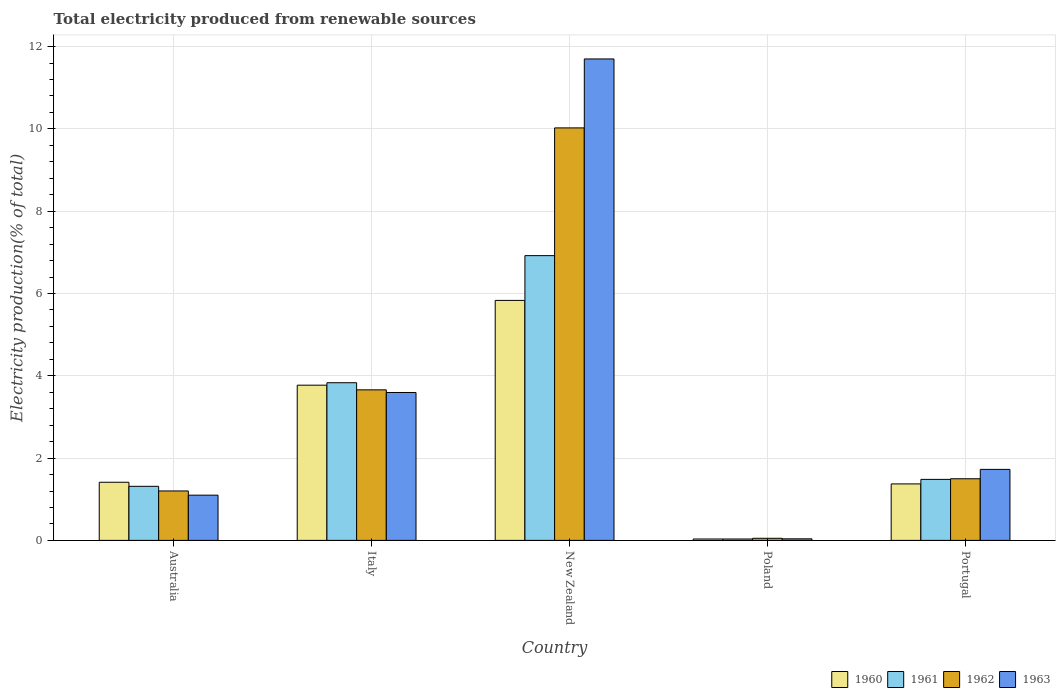How many different coloured bars are there?
Give a very brief answer. 4. Are the number of bars on each tick of the X-axis equal?
Provide a short and direct response. Yes. What is the label of the 3rd group of bars from the left?
Ensure brevity in your answer.  New Zealand. What is the total electricity produced in 1963 in Italy?
Provide a succinct answer. 3.59. Across all countries, what is the maximum total electricity produced in 1963?
Provide a succinct answer. 11.7. Across all countries, what is the minimum total electricity produced in 1963?
Provide a succinct answer. 0.04. In which country was the total electricity produced in 1962 maximum?
Your response must be concise. New Zealand. What is the total total electricity produced in 1960 in the graph?
Provide a succinct answer. 12.42. What is the difference between the total electricity produced in 1962 in New Zealand and that in Portugal?
Your answer should be very brief. 8.53. What is the difference between the total electricity produced in 1962 in Poland and the total electricity produced in 1960 in New Zealand?
Offer a terse response. -5.78. What is the average total electricity produced in 1961 per country?
Ensure brevity in your answer.  2.72. What is the difference between the total electricity produced of/in 1962 and total electricity produced of/in 1963 in Italy?
Give a very brief answer. 0.06. In how many countries, is the total electricity produced in 1961 greater than 6 %?
Provide a succinct answer. 1. What is the ratio of the total electricity produced in 1962 in Poland to that in Portugal?
Your answer should be compact. 0.03. Is the total electricity produced in 1963 in Australia less than that in Poland?
Your answer should be compact. No. Is the difference between the total electricity produced in 1962 in Poland and Portugal greater than the difference between the total electricity produced in 1963 in Poland and Portugal?
Keep it short and to the point. Yes. What is the difference between the highest and the second highest total electricity produced in 1962?
Offer a very short reply. -8.53. What is the difference between the highest and the lowest total electricity produced in 1962?
Give a very brief answer. 9.97. In how many countries, is the total electricity produced in 1960 greater than the average total electricity produced in 1960 taken over all countries?
Provide a succinct answer. 2. Is it the case that in every country, the sum of the total electricity produced in 1962 and total electricity produced in 1961 is greater than the sum of total electricity produced in 1960 and total electricity produced in 1963?
Give a very brief answer. No. What does the 1st bar from the left in Italy represents?
Provide a succinct answer. 1960. Is it the case that in every country, the sum of the total electricity produced in 1962 and total electricity produced in 1961 is greater than the total electricity produced in 1960?
Give a very brief answer. Yes. How many bars are there?
Provide a succinct answer. 20. Are all the bars in the graph horizontal?
Offer a terse response. No. What is the difference between two consecutive major ticks on the Y-axis?
Keep it short and to the point. 2. Does the graph contain any zero values?
Provide a succinct answer. No. Where does the legend appear in the graph?
Give a very brief answer. Bottom right. How many legend labels are there?
Your answer should be very brief. 4. How are the legend labels stacked?
Offer a very short reply. Horizontal. What is the title of the graph?
Your answer should be compact. Total electricity produced from renewable sources. What is the label or title of the X-axis?
Offer a very short reply. Country. What is the label or title of the Y-axis?
Provide a succinct answer. Electricity production(% of total). What is the Electricity production(% of total) of 1960 in Australia?
Make the answer very short. 1.41. What is the Electricity production(% of total) of 1961 in Australia?
Make the answer very short. 1.31. What is the Electricity production(% of total) in 1962 in Australia?
Ensure brevity in your answer.  1.2. What is the Electricity production(% of total) in 1963 in Australia?
Make the answer very short. 1.1. What is the Electricity production(% of total) of 1960 in Italy?
Provide a short and direct response. 3.77. What is the Electricity production(% of total) in 1961 in Italy?
Your answer should be very brief. 3.83. What is the Electricity production(% of total) of 1962 in Italy?
Provide a short and direct response. 3.66. What is the Electricity production(% of total) of 1963 in Italy?
Your response must be concise. 3.59. What is the Electricity production(% of total) of 1960 in New Zealand?
Make the answer very short. 5.83. What is the Electricity production(% of total) of 1961 in New Zealand?
Give a very brief answer. 6.92. What is the Electricity production(% of total) in 1962 in New Zealand?
Your response must be concise. 10.02. What is the Electricity production(% of total) of 1963 in New Zealand?
Your answer should be compact. 11.7. What is the Electricity production(% of total) of 1960 in Poland?
Make the answer very short. 0.03. What is the Electricity production(% of total) of 1961 in Poland?
Provide a short and direct response. 0.03. What is the Electricity production(% of total) of 1962 in Poland?
Give a very brief answer. 0.05. What is the Electricity production(% of total) of 1963 in Poland?
Keep it short and to the point. 0.04. What is the Electricity production(% of total) of 1960 in Portugal?
Provide a short and direct response. 1.37. What is the Electricity production(% of total) of 1961 in Portugal?
Provide a short and direct response. 1.48. What is the Electricity production(% of total) of 1962 in Portugal?
Provide a short and direct response. 1.5. What is the Electricity production(% of total) in 1963 in Portugal?
Provide a short and direct response. 1.73. Across all countries, what is the maximum Electricity production(% of total) in 1960?
Your response must be concise. 5.83. Across all countries, what is the maximum Electricity production(% of total) in 1961?
Offer a very short reply. 6.92. Across all countries, what is the maximum Electricity production(% of total) of 1962?
Give a very brief answer. 10.02. Across all countries, what is the maximum Electricity production(% of total) in 1963?
Keep it short and to the point. 11.7. Across all countries, what is the minimum Electricity production(% of total) in 1960?
Give a very brief answer. 0.03. Across all countries, what is the minimum Electricity production(% of total) of 1961?
Your response must be concise. 0.03. Across all countries, what is the minimum Electricity production(% of total) in 1962?
Ensure brevity in your answer.  0.05. Across all countries, what is the minimum Electricity production(% of total) in 1963?
Your response must be concise. 0.04. What is the total Electricity production(% of total) in 1960 in the graph?
Your response must be concise. 12.42. What is the total Electricity production(% of total) of 1961 in the graph?
Offer a very short reply. 13.58. What is the total Electricity production(% of total) of 1962 in the graph?
Offer a terse response. 16.43. What is the total Electricity production(% of total) in 1963 in the graph?
Ensure brevity in your answer.  18.16. What is the difference between the Electricity production(% of total) in 1960 in Australia and that in Italy?
Your answer should be very brief. -2.36. What is the difference between the Electricity production(% of total) in 1961 in Australia and that in Italy?
Make the answer very short. -2.52. What is the difference between the Electricity production(% of total) in 1962 in Australia and that in Italy?
Ensure brevity in your answer.  -2.46. What is the difference between the Electricity production(% of total) in 1963 in Australia and that in Italy?
Ensure brevity in your answer.  -2.5. What is the difference between the Electricity production(% of total) in 1960 in Australia and that in New Zealand?
Your answer should be compact. -4.42. What is the difference between the Electricity production(% of total) of 1961 in Australia and that in New Zealand?
Your answer should be very brief. -5.61. What is the difference between the Electricity production(% of total) of 1962 in Australia and that in New Zealand?
Your answer should be very brief. -8.82. What is the difference between the Electricity production(% of total) of 1963 in Australia and that in New Zealand?
Offer a very short reply. -10.6. What is the difference between the Electricity production(% of total) of 1960 in Australia and that in Poland?
Offer a terse response. 1.38. What is the difference between the Electricity production(% of total) in 1961 in Australia and that in Poland?
Offer a terse response. 1.28. What is the difference between the Electricity production(% of total) in 1962 in Australia and that in Poland?
Your answer should be very brief. 1.15. What is the difference between the Electricity production(% of total) of 1963 in Australia and that in Poland?
Ensure brevity in your answer.  1.06. What is the difference between the Electricity production(% of total) in 1960 in Australia and that in Portugal?
Ensure brevity in your answer.  0.04. What is the difference between the Electricity production(% of total) in 1961 in Australia and that in Portugal?
Provide a succinct answer. -0.17. What is the difference between the Electricity production(% of total) of 1962 in Australia and that in Portugal?
Your response must be concise. -0.3. What is the difference between the Electricity production(% of total) in 1963 in Australia and that in Portugal?
Keep it short and to the point. -0.63. What is the difference between the Electricity production(% of total) of 1960 in Italy and that in New Zealand?
Make the answer very short. -2.06. What is the difference between the Electricity production(% of total) in 1961 in Italy and that in New Zealand?
Offer a very short reply. -3.09. What is the difference between the Electricity production(% of total) in 1962 in Italy and that in New Zealand?
Make the answer very short. -6.37. What is the difference between the Electricity production(% of total) in 1963 in Italy and that in New Zealand?
Give a very brief answer. -8.11. What is the difference between the Electricity production(% of total) in 1960 in Italy and that in Poland?
Give a very brief answer. 3.74. What is the difference between the Electricity production(% of total) in 1961 in Italy and that in Poland?
Provide a succinct answer. 3.8. What is the difference between the Electricity production(% of total) in 1962 in Italy and that in Poland?
Give a very brief answer. 3.61. What is the difference between the Electricity production(% of total) of 1963 in Italy and that in Poland?
Give a very brief answer. 3.56. What is the difference between the Electricity production(% of total) in 1960 in Italy and that in Portugal?
Your answer should be compact. 2.4. What is the difference between the Electricity production(% of total) of 1961 in Italy and that in Portugal?
Ensure brevity in your answer.  2.35. What is the difference between the Electricity production(% of total) of 1962 in Italy and that in Portugal?
Offer a very short reply. 2.16. What is the difference between the Electricity production(% of total) of 1963 in Italy and that in Portugal?
Make the answer very short. 1.87. What is the difference between the Electricity production(% of total) of 1960 in New Zealand and that in Poland?
Give a very brief answer. 5.8. What is the difference between the Electricity production(% of total) in 1961 in New Zealand and that in Poland?
Ensure brevity in your answer.  6.89. What is the difference between the Electricity production(% of total) of 1962 in New Zealand and that in Poland?
Offer a terse response. 9.97. What is the difference between the Electricity production(% of total) of 1963 in New Zealand and that in Poland?
Offer a very short reply. 11.66. What is the difference between the Electricity production(% of total) in 1960 in New Zealand and that in Portugal?
Offer a terse response. 4.46. What is the difference between the Electricity production(% of total) in 1961 in New Zealand and that in Portugal?
Give a very brief answer. 5.44. What is the difference between the Electricity production(% of total) of 1962 in New Zealand and that in Portugal?
Ensure brevity in your answer.  8.53. What is the difference between the Electricity production(% of total) in 1963 in New Zealand and that in Portugal?
Give a very brief answer. 9.97. What is the difference between the Electricity production(% of total) in 1960 in Poland and that in Portugal?
Keep it short and to the point. -1.34. What is the difference between the Electricity production(% of total) of 1961 in Poland and that in Portugal?
Provide a short and direct response. -1.45. What is the difference between the Electricity production(% of total) of 1962 in Poland and that in Portugal?
Offer a terse response. -1.45. What is the difference between the Electricity production(% of total) in 1963 in Poland and that in Portugal?
Offer a very short reply. -1.69. What is the difference between the Electricity production(% of total) of 1960 in Australia and the Electricity production(% of total) of 1961 in Italy?
Your answer should be compact. -2.42. What is the difference between the Electricity production(% of total) in 1960 in Australia and the Electricity production(% of total) in 1962 in Italy?
Provide a succinct answer. -2.25. What is the difference between the Electricity production(% of total) of 1960 in Australia and the Electricity production(% of total) of 1963 in Italy?
Your response must be concise. -2.18. What is the difference between the Electricity production(% of total) of 1961 in Australia and the Electricity production(% of total) of 1962 in Italy?
Provide a succinct answer. -2.34. What is the difference between the Electricity production(% of total) of 1961 in Australia and the Electricity production(% of total) of 1963 in Italy?
Keep it short and to the point. -2.28. What is the difference between the Electricity production(% of total) of 1962 in Australia and the Electricity production(% of total) of 1963 in Italy?
Offer a terse response. -2.39. What is the difference between the Electricity production(% of total) in 1960 in Australia and the Electricity production(% of total) in 1961 in New Zealand?
Offer a terse response. -5.51. What is the difference between the Electricity production(% of total) in 1960 in Australia and the Electricity production(% of total) in 1962 in New Zealand?
Ensure brevity in your answer.  -8.61. What is the difference between the Electricity production(% of total) in 1960 in Australia and the Electricity production(% of total) in 1963 in New Zealand?
Your answer should be very brief. -10.29. What is the difference between the Electricity production(% of total) of 1961 in Australia and the Electricity production(% of total) of 1962 in New Zealand?
Your answer should be compact. -8.71. What is the difference between the Electricity production(% of total) in 1961 in Australia and the Electricity production(% of total) in 1963 in New Zealand?
Give a very brief answer. -10.39. What is the difference between the Electricity production(% of total) in 1962 in Australia and the Electricity production(% of total) in 1963 in New Zealand?
Provide a short and direct response. -10.5. What is the difference between the Electricity production(% of total) of 1960 in Australia and the Electricity production(% of total) of 1961 in Poland?
Keep it short and to the point. 1.38. What is the difference between the Electricity production(% of total) in 1960 in Australia and the Electricity production(% of total) in 1962 in Poland?
Offer a very short reply. 1.36. What is the difference between the Electricity production(% of total) of 1960 in Australia and the Electricity production(% of total) of 1963 in Poland?
Your response must be concise. 1.37. What is the difference between the Electricity production(% of total) of 1961 in Australia and the Electricity production(% of total) of 1962 in Poland?
Offer a very short reply. 1.26. What is the difference between the Electricity production(% of total) of 1961 in Australia and the Electricity production(% of total) of 1963 in Poland?
Make the answer very short. 1.28. What is the difference between the Electricity production(% of total) in 1962 in Australia and the Electricity production(% of total) in 1963 in Poland?
Offer a very short reply. 1.16. What is the difference between the Electricity production(% of total) in 1960 in Australia and the Electricity production(% of total) in 1961 in Portugal?
Provide a short and direct response. -0.07. What is the difference between the Electricity production(% of total) in 1960 in Australia and the Electricity production(% of total) in 1962 in Portugal?
Make the answer very short. -0.09. What is the difference between the Electricity production(% of total) of 1960 in Australia and the Electricity production(% of total) of 1963 in Portugal?
Give a very brief answer. -0.31. What is the difference between the Electricity production(% of total) of 1961 in Australia and the Electricity production(% of total) of 1962 in Portugal?
Offer a very short reply. -0.18. What is the difference between the Electricity production(% of total) of 1961 in Australia and the Electricity production(% of total) of 1963 in Portugal?
Keep it short and to the point. -0.41. What is the difference between the Electricity production(% of total) in 1962 in Australia and the Electricity production(% of total) in 1963 in Portugal?
Offer a terse response. -0.52. What is the difference between the Electricity production(% of total) in 1960 in Italy and the Electricity production(% of total) in 1961 in New Zealand?
Offer a terse response. -3.15. What is the difference between the Electricity production(% of total) of 1960 in Italy and the Electricity production(% of total) of 1962 in New Zealand?
Provide a short and direct response. -6.25. What is the difference between the Electricity production(% of total) of 1960 in Italy and the Electricity production(% of total) of 1963 in New Zealand?
Offer a terse response. -7.93. What is the difference between the Electricity production(% of total) of 1961 in Italy and the Electricity production(% of total) of 1962 in New Zealand?
Provide a short and direct response. -6.19. What is the difference between the Electricity production(% of total) of 1961 in Italy and the Electricity production(% of total) of 1963 in New Zealand?
Provide a short and direct response. -7.87. What is the difference between the Electricity production(% of total) of 1962 in Italy and the Electricity production(% of total) of 1963 in New Zealand?
Give a very brief answer. -8.04. What is the difference between the Electricity production(% of total) in 1960 in Italy and the Electricity production(% of total) in 1961 in Poland?
Provide a succinct answer. 3.74. What is the difference between the Electricity production(% of total) of 1960 in Italy and the Electricity production(% of total) of 1962 in Poland?
Ensure brevity in your answer.  3.72. What is the difference between the Electricity production(% of total) of 1960 in Italy and the Electricity production(% of total) of 1963 in Poland?
Ensure brevity in your answer.  3.73. What is the difference between the Electricity production(% of total) of 1961 in Italy and the Electricity production(% of total) of 1962 in Poland?
Your answer should be compact. 3.78. What is the difference between the Electricity production(% of total) of 1961 in Italy and the Electricity production(% of total) of 1963 in Poland?
Your answer should be compact. 3.79. What is the difference between the Electricity production(% of total) of 1962 in Italy and the Electricity production(% of total) of 1963 in Poland?
Your response must be concise. 3.62. What is the difference between the Electricity production(% of total) of 1960 in Italy and the Electricity production(% of total) of 1961 in Portugal?
Ensure brevity in your answer.  2.29. What is the difference between the Electricity production(% of total) of 1960 in Italy and the Electricity production(% of total) of 1962 in Portugal?
Keep it short and to the point. 2.27. What is the difference between the Electricity production(% of total) in 1960 in Italy and the Electricity production(% of total) in 1963 in Portugal?
Make the answer very short. 2.05. What is the difference between the Electricity production(% of total) in 1961 in Italy and the Electricity production(% of total) in 1962 in Portugal?
Offer a terse response. 2.33. What is the difference between the Electricity production(% of total) in 1961 in Italy and the Electricity production(% of total) in 1963 in Portugal?
Provide a succinct answer. 2.11. What is the difference between the Electricity production(% of total) of 1962 in Italy and the Electricity production(% of total) of 1963 in Portugal?
Ensure brevity in your answer.  1.93. What is the difference between the Electricity production(% of total) in 1960 in New Zealand and the Electricity production(% of total) in 1961 in Poland?
Provide a short and direct response. 5.8. What is the difference between the Electricity production(% of total) of 1960 in New Zealand and the Electricity production(% of total) of 1962 in Poland?
Keep it short and to the point. 5.78. What is the difference between the Electricity production(% of total) of 1960 in New Zealand and the Electricity production(% of total) of 1963 in Poland?
Give a very brief answer. 5.79. What is the difference between the Electricity production(% of total) of 1961 in New Zealand and the Electricity production(% of total) of 1962 in Poland?
Offer a very short reply. 6.87. What is the difference between the Electricity production(% of total) of 1961 in New Zealand and the Electricity production(% of total) of 1963 in Poland?
Give a very brief answer. 6.88. What is the difference between the Electricity production(% of total) of 1962 in New Zealand and the Electricity production(% of total) of 1963 in Poland?
Offer a terse response. 9.99. What is the difference between the Electricity production(% of total) in 1960 in New Zealand and the Electricity production(% of total) in 1961 in Portugal?
Make the answer very short. 4.35. What is the difference between the Electricity production(% of total) of 1960 in New Zealand and the Electricity production(% of total) of 1962 in Portugal?
Make the answer very short. 4.33. What is the difference between the Electricity production(% of total) of 1960 in New Zealand and the Electricity production(% of total) of 1963 in Portugal?
Your answer should be compact. 4.11. What is the difference between the Electricity production(% of total) of 1961 in New Zealand and the Electricity production(% of total) of 1962 in Portugal?
Offer a terse response. 5.42. What is the difference between the Electricity production(% of total) in 1961 in New Zealand and the Electricity production(% of total) in 1963 in Portugal?
Offer a terse response. 5.19. What is the difference between the Electricity production(% of total) in 1962 in New Zealand and the Electricity production(% of total) in 1963 in Portugal?
Provide a short and direct response. 8.3. What is the difference between the Electricity production(% of total) of 1960 in Poland and the Electricity production(% of total) of 1961 in Portugal?
Your answer should be very brief. -1.45. What is the difference between the Electricity production(% of total) in 1960 in Poland and the Electricity production(% of total) in 1962 in Portugal?
Offer a very short reply. -1.46. What is the difference between the Electricity production(% of total) of 1960 in Poland and the Electricity production(% of total) of 1963 in Portugal?
Provide a succinct answer. -1.69. What is the difference between the Electricity production(% of total) in 1961 in Poland and the Electricity production(% of total) in 1962 in Portugal?
Give a very brief answer. -1.46. What is the difference between the Electricity production(% of total) of 1961 in Poland and the Electricity production(% of total) of 1963 in Portugal?
Keep it short and to the point. -1.69. What is the difference between the Electricity production(% of total) in 1962 in Poland and the Electricity production(% of total) in 1963 in Portugal?
Your response must be concise. -1.67. What is the average Electricity production(% of total) in 1960 per country?
Your answer should be very brief. 2.48. What is the average Electricity production(% of total) in 1961 per country?
Provide a short and direct response. 2.72. What is the average Electricity production(% of total) in 1962 per country?
Offer a very short reply. 3.29. What is the average Electricity production(% of total) of 1963 per country?
Your response must be concise. 3.63. What is the difference between the Electricity production(% of total) in 1960 and Electricity production(% of total) in 1961 in Australia?
Give a very brief answer. 0.1. What is the difference between the Electricity production(% of total) in 1960 and Electricity production(% of total) in 1962 in Australia?
Your response must be concise. 0.21. What is the difference between the Electricity production(% of total) in 1960 and Electricity production(% of total) in 1963 in Australia?
Offer a very short reply. 0.31. What is the difference between the Electricity production(% of total) of 1961 and Electricity production(% of total) of 1962 in Australia?
Provide a short and direct response. 0.11. What is the difference between the Electricity production(% of total) in 1961 and Electricity production(% of total) in 1963 in Australia?
Give a very brief answer. 0.21. What is the difference between the Electricity production(% of total) of 1962 and Electricity production(% of total) of 1963 in Australia?
Provide a short and direct response. 0.1. What is the difference between the Electricity production(% of total) of 1960 and Electricity production(% of total) of 1961 in Italy?
Offer a terse response. -0.06. What is the difference between the Electricity production(% of total) in 1960 and Electricity production(% of total) in 1962 in Italy?
Provide a succinct answer. 0.11. What is the difference between the Electricity production(% of total) in 1960 and Electricity production(% of total) in 1963 in Italy?
Provide a short and direct response. 0.18. What is the difference between the Electricity production(% of total) of 1961 and Electricity production(% of total) of 1962 in Italy?
Give a very brief answer. 0.17. What is the difference between the Electricity production(% of total) in 1961 and Electricity production(% of total) in 1963 in Italy?
Ensure brevity in your answer.  0.24. What is the difference between the Electricity production(% of total) of 1962 and Electricity production(% of total) of 1963 in Italy?
Provide a short and direct response. 0.06. What is the difference between the Electricity production(% of total) in 1960 and Electricity production(% of total) in 1961 in New Zealand?
Make the answer very short. -1.09. What is the difference between the Electricity production(% of total) in 1960 and Electricity production(% of total) in 1962 in New Zealand?
Your response must be concise. -4.19. What is the difference between the Electricity production(% of total) of 1960 and Electricity production(% of total) of 1963 in New Zealand?
Provide a short and direct response. -5.87. What is the difference between the Electricity production(% of total) in 1961 and Electricity production(% of total) in 1962 in New Zealand?
Keep it short and to the point. -3.1. What is the difference between the Electricity production(% of total) in 1961 and Electricity production(% of total) in 1963 in New Zealand?
Provide a succinct answer. -4.78. What is the difference between the Electricity production(% of total) in 1962 and Electricity production(% of total) in 1963 in New Zealand?
Provide a succinct answer. -1.68. What is the difference between the Electricity production(% of total) in 1960 and Electricity production(% of total) in 1962 in Poland?
Your answer should be compact. -0.02. What is the difference between the Electricity production(% of total) in 1960 and Electricity production(% of total) in 1963 in Poland?
Offer a very short reply. -0. What is the difference between the Electricity production(% of total) of 1961 and Electricity production(% of total) of 1962 in Poland?
Your answer should be compact. -0.02. What is the difference between the Electricity production(% of total) of 1961 and Electricity production(% of total) of 1963 in Poland?
Your answer should be very brief. -0. What is the difference between the Electricity production(% of total) of 1962 and Electricity production(% of total) of 1963 in Poland?
Provide a short and direct response. 0.01. What is the difference between the Electricity production(% of total) of 1960 and Electricity production(% of total) of 1961 in Portugal?
Provide a succinct answer. -0.11. What is the difference between the Electricity production(% of total) in 1960 and Electricity production(% of total) in 1962 in Portugal?
Offer a very short reply. -0.13. What is the difference between the Electricity production(% of total) of 1960 and Electricity production(% of total) of 1963 in Portugal?
Your answer should be very brief. -0.35. What is the difference between the Electricity production(% of total) in 1961 and Electricity production(% of total) in 1962 in Portugal?
Your answer should be very brief. -0.02. What is the difference between the Electricity production(% of total) in 1961 and Electricity production(% of total) in 1963 in Portugal?
Provide a succinct answer. -0.24. What is the difference between the Electricity production(% of total) in 1962 and Electricity production(% of total) in 1963 in Portugal?
Make the answer very short. -0.23. What is the ratio of the Electricity production(% of total) of 1960 in Australia to that in Italy?
Provide a succinct answer. 0.37. What is the ratio of the Electricity production(% of total) in 1961 in Australia to that in Italy?
Provide a short and direct response. 0.34. What is the ratio of the Electricity production(% of total) of 1962 in Australia to that in Italy?
Your answer should be very brief. 0.33. What is the ratio of the Electricity production(% of total) in 1963 in Australia to that in Italy?
Provide a succinct answer. 0.31. What is the ratio of the Electricity production(% of total) of 1960 in Australia to that in New Zealand?
Give a very brief answer. 0.24. What is the ratio of the Electricity production(% of total) in 1961 in Australia to that in New Zealand?
Give a very brief answer. 0.19. What is the ratio of the Electricity production(% of total) of 1962 in Australia to that in New Zealand?
Make the answer very short. 0.12. What is the ratio of the Electricity production(% of total) in 1963 in Australia to that in New Zealand?
Keep it short and to the point. 0.09. What is the ratio of the Electricity production(% of total) of 1960 in Australia to that in Poland?
Your answer should be compact. 41.37. What is the ratio of the Electricity production(% of total) of 1961 in Australia to that in Poland?
Your answer should be compact. 38.51. What is the ratio of the Electricity production(% of total) in 1962 in Australia to that in Poland?
Offer a terse response. 23.61. What is the ratio of the Electricity production(% of total) of 1963 in Australia to that in Poland?
Keep it short and to the point. 29. What is the ratio of the Electricity production(% of total) in 1960 in Australia to that in Portugal?
Provide a succinct answer. 1.03. What is the ratio of the Electricity production(% of total) of 1961 in Australia to that in Portugal?
Your answer should be compact. 0.89. What is the ratio of the Electricity production(% of total) in 1962 in Australia to that in Portugal?
Give a very brief answer. 0.8. What is the ratio of the Electricity production(% of total) of 1963 in Australia to that in Portugal?
Offer a very short reply. 0.64. What is the ratio of the Electricity production(% of total) of 1960 in Italy to that in New Zealand?
Make the answer very short. 0.65. What is the ratio of the Electricity production(% of total) of 1961 in Italy to that in New Zealand?
Ensure brevity in your answer.  0.55. What is the ratio of the Electricity production(% of total) in 1962 in Italy to that in New Zealand?
Provide a short and direct response. 0.36. What is the ratio of the Electricity production(% of total) in 1963 in Italy to that in New Zealand?
Provide a succinct answer. 0.31. What is the ratio of the Electricity production(% of total) of 1960 in Italy to that in Poland?
Provide a short and direct response. 110.45. What is the ratio of the Electricity production(% of total) in 1961 in Italy to that in Poland?
Make the answer very short. 112.3. What is the ratio of the Electricity production(% of total) of 1962 in Italy to that in Poland?
Give a very brief answer. 71.88. What is the ratio of the Electricity production(% of total) in 1963 in Italy to that in Poland?
Your response must be concise. 94.84. What is the ratio of the Electricity production(% of total) of 1960 in Italy to that in Portugal?
Provide a short and direct response. 2.75. What is the ratio of the Electricity production(% of total) in 1961 in Italy to that in Portugal?
Your answer should be compact. 2.58. What is the ratio of the Electricity production(% of total) in 1962 in Italy to that in Portugal?
Make the answer very short. 2.44. What is the ratio of the Electricity production(% of total) of 1963 in Italy to that in Portugal?
Keep it short and to the point. 2.08. What is the ratio of the Electricity production(% of total) in 1960 in New Zealand to that in Poland?
Your answer should be compact. 170.79. What is the ratio of the Electricity production(% of total) in 1961 in New Zealand to that in Poland?
Provide a short and direct response. 202.83. What is the ratio of the Electricity production(% of total) in 1962 in New Zealand to that in Poland?
Provide a succinct answer. 196.95. What is the ratio of the Electricity production(% of total) in 1963 in New Zealand to that in Poland?
Give a very brief answer. 308.73. What is the ratio of the Electricity production(% of total) of 1960 in New Zealand to that in Portugal?
Give a very brief answer. 4.25. What is the ratio of the Electricity production(% of total) of 1961 in New Zealand to that in Portugal?
Provide a short and direct response. 4.67. What is the ratio of the Electricity production(% of total) in 1962 in New Zealand to that in Portugal?
Your response must be concise. 6.69. What is the ratio of the Electricity production(% of total) in 1963 in New Zealand to that in Portugal?
Ensure brevity in your answer.  6.78. What is the ratio of the Electricity production(% of total) in 1960 in Poland to that in Portugal?
Offer a terse response. 0.02. What is the ratio of the Electricity production(% of total) in 1961 in Poland to that in Portugal?
Your response must be concise. 0.02. What is the ratio of the Electricity production(% of total) of 1962 in Poland to that in Portugal?
Offer a very short reply. 0.03. What is the ratio of the Electricity production(% of total) in 1963 in Poland to that in Portugal?
Your answer should be very brief. 0.02. What is the difference between the highest and the second highest Electricity production(% of total) in 1960?
Ensure brevity in your answer.  2.06. What is the difference between the highest and the second highest Electricity production(% of total) in 1961?
Make the answer very short. 3.09. What is the difference between the highest and the second highest Electricity production(% of total) in 1962?
Ensure brevity in your answer.  6.37. What is the difference between the highest and the second highest Electricity production(% of total) of 1963?
Provide a short and direct response. 8.11. What is the difference between the highest and the lowest Electricity production(% of total) of 1960?
Provide a short and direct response. 5.8. What is the difference between the highest and the lowest Electricity production(% of total) of 1961?
Offer a terse response. 6.89. What is the difference between the highest and the lowest Electricity production(% of total) in 1962?
Your response must be concise. 9.97. What is the difference between the highest and the lowest Electricity production(% of total) in 1963?
Keep it short and to the point. 11.66. 